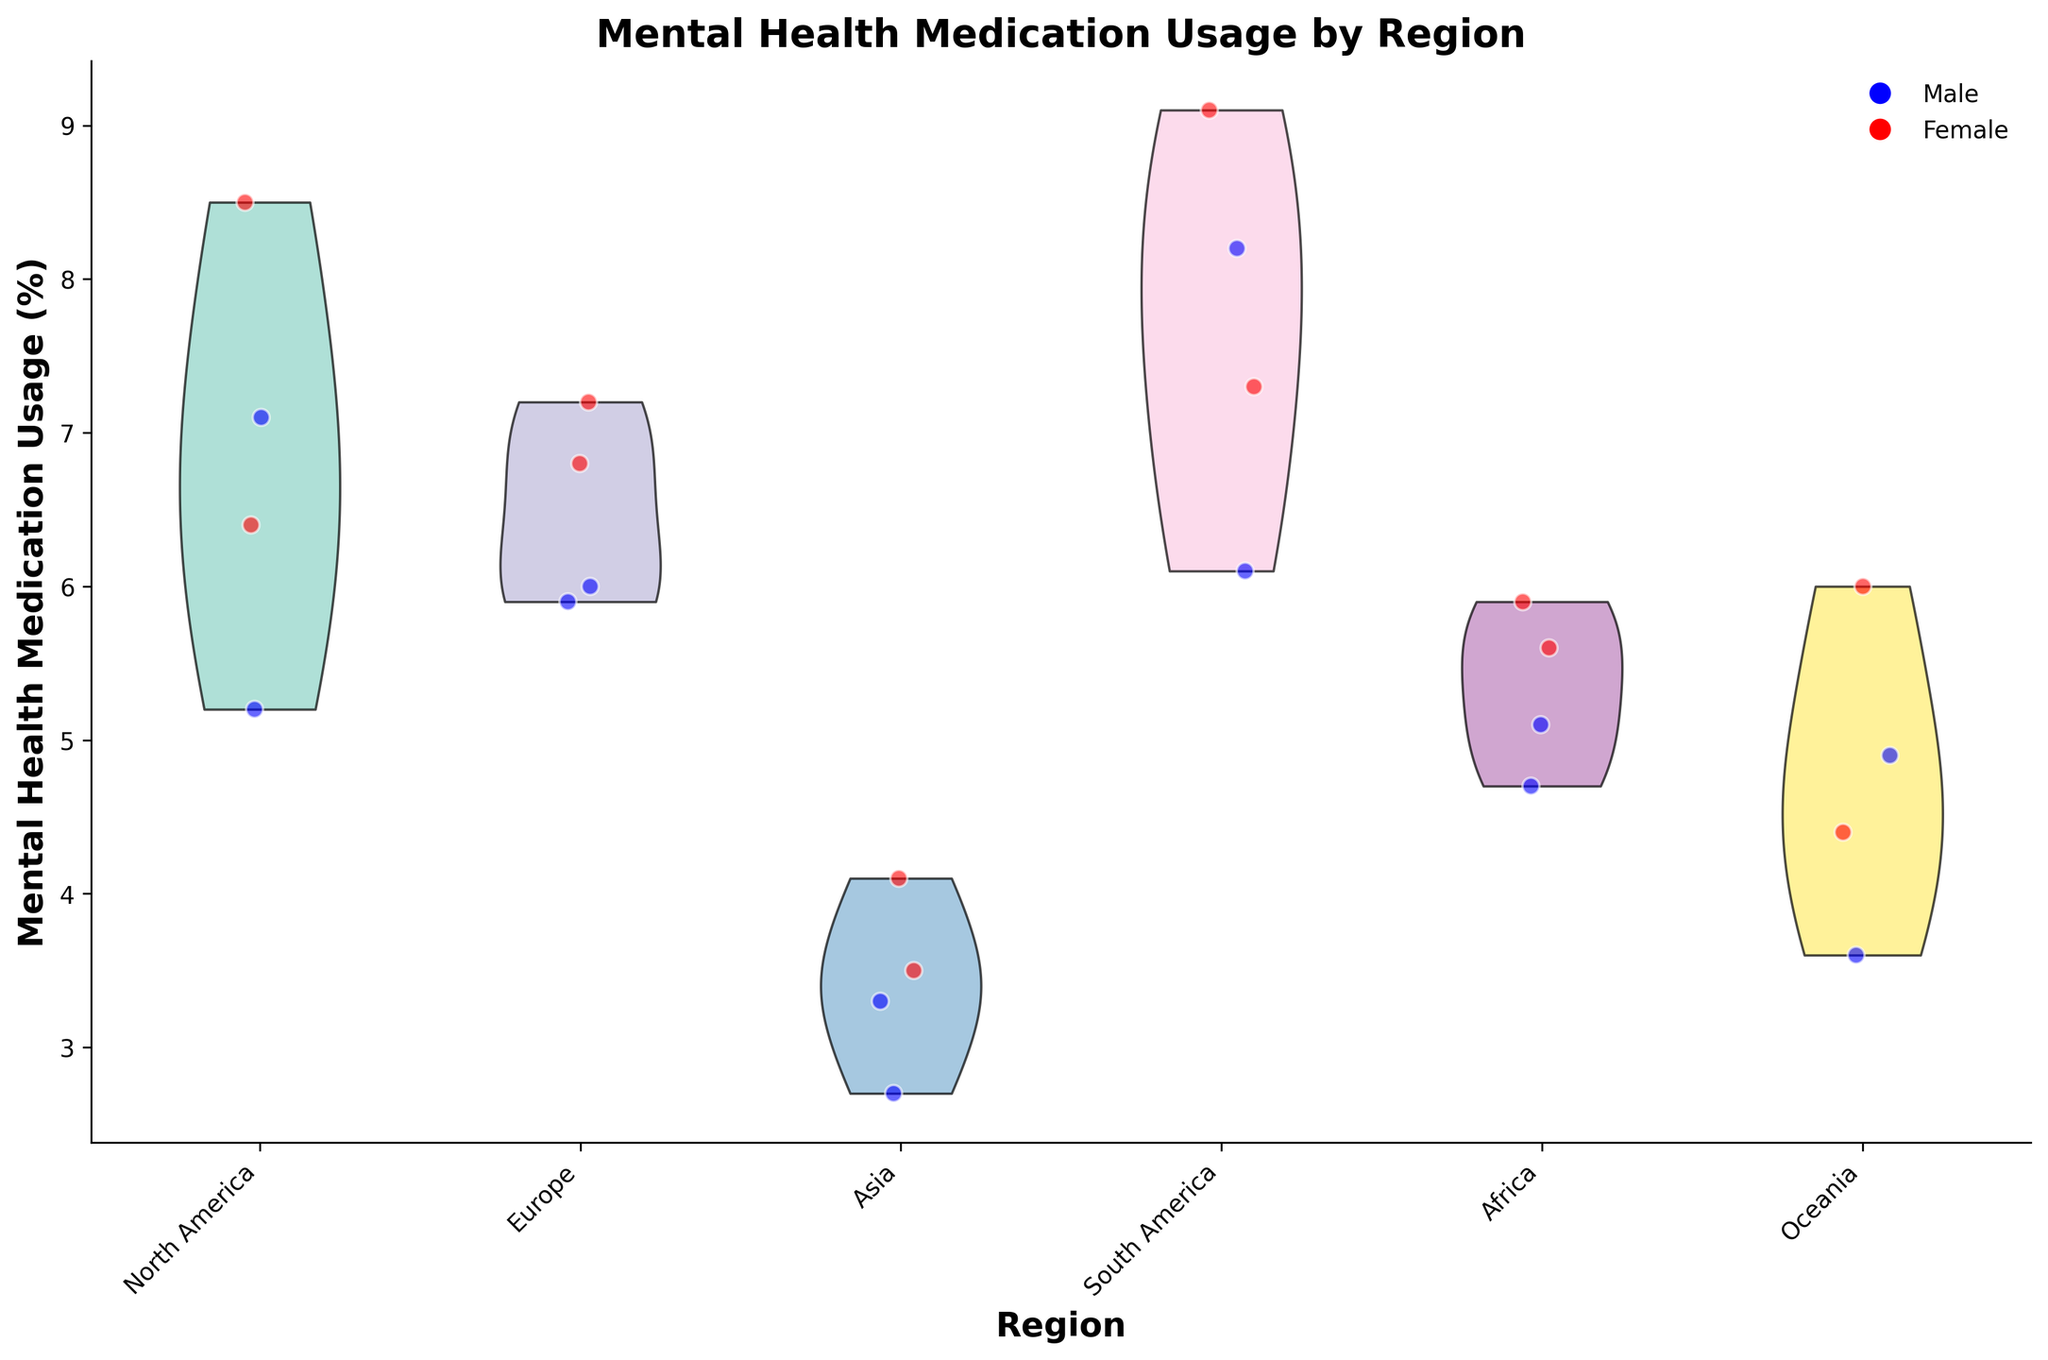What is the title of the figure? The title of the figure is typically located at the top of the graph and is usually the most prominent text. For this figure, it reads "Mental Health Medication Usage by Region."
Answer: Mental Health Medication Usage by Region How is gender visually differentiated in the scatter plots? Gender differences are indicated using color coding in the scatter points with blue representing males and red representing females. This color scheme can be identified by the legend.
Answer: By color, blue for males and red for females Which region has the highest mental health medication usage? By looking at the scatter points, the region with the highest values on the vertical axis (Mental Health Medication Usage) is North America, particularly for males and females aged 25-34.
Answer: North America In which region do males aged 55-64 have the lowest mental health medication usage? By examining the scatter points and their distribution across regions for males aged 55-64, the lowest usage is found in Asia, as indicated by the positioning of the relevant scatter points.
Answer: Asia How does the mental health medication usage of females in Europe compare to that of females in Africa for the 35-44 age group? For the 35-44 age group, females in Europe have higher usage values than females in Africa, as evidenced by the higher positioning of the scatter points in Europe compared to Africa.
Answer: Higher in Europe What is the approximate mental health medication usage percentage for males aged 15-24 in South America? Locate the scatter point corresponding to males aged 15-24 in the South America region. The point is plotted just above the six on the vertical axis, so the usage is around 6.1%.
Answer: 6.1% What can be inferred from the shape of the violins for the North America region? The shape of the violins represents the distribution of mental health medication usage. For North America, the violins indicate a wider distribution and a concentration of higher values, particularly around the upper percentiles, indicating varied and generally high usage.
Answer: Wide distribution with concentrated higher values Which region shows the smallest difference in mental health medication usage between males and females aged 45-54? Compare the scatter points for males and females aged 45-54 in each region. The smallest difference is observed in Europe, where the points for males and females are closer together.
Answer: Europe How do the points and violins help in interpreting the data across different regions? The scatter points provide detailed individual data points for different age and gender groups, whereas the violin plots give an overall distribution view. This combination helps in understanding both individual variations and broader trends within each region.
Answer: Individual variations and broader trends Do males or females generally have higher mental health medication usage across all regions? From a general observation of scatter point positions, females tend to have higher mental health medication usage across all regions, as indicated by the generally higher positions of red points compared to blue points.
Answer: Females 